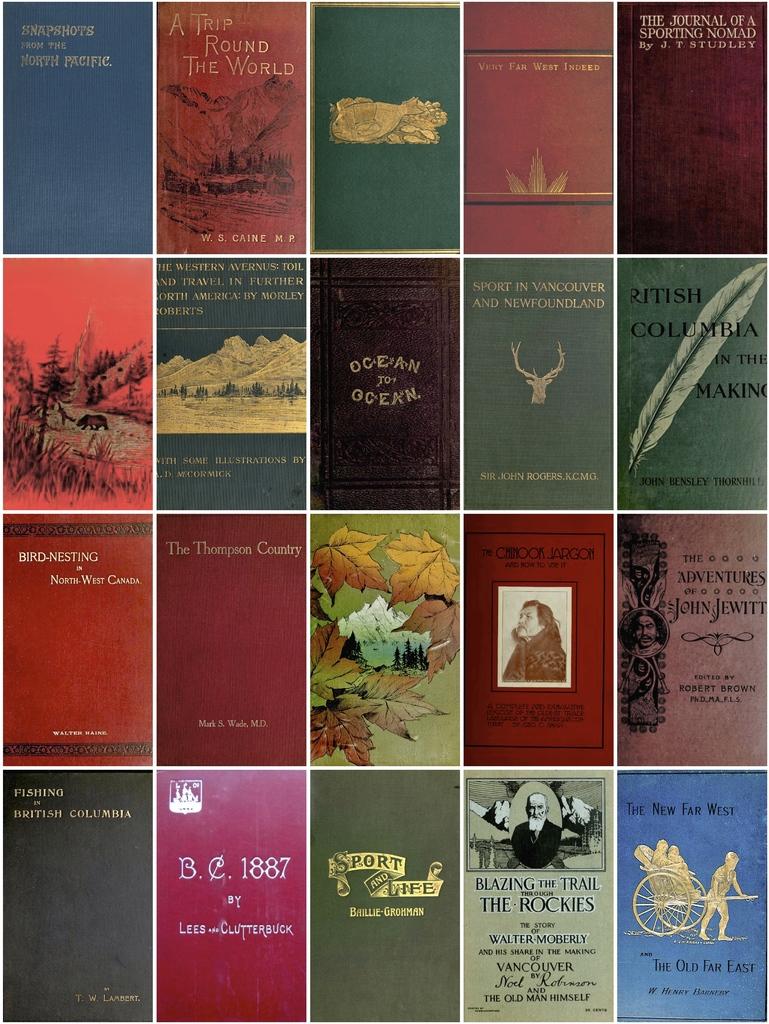What is the name of one of the books?
Ensure brevity in your answer.  Ocean to ocean. Who is one of the authors?
Offer a very short reply. Unanswerable. 